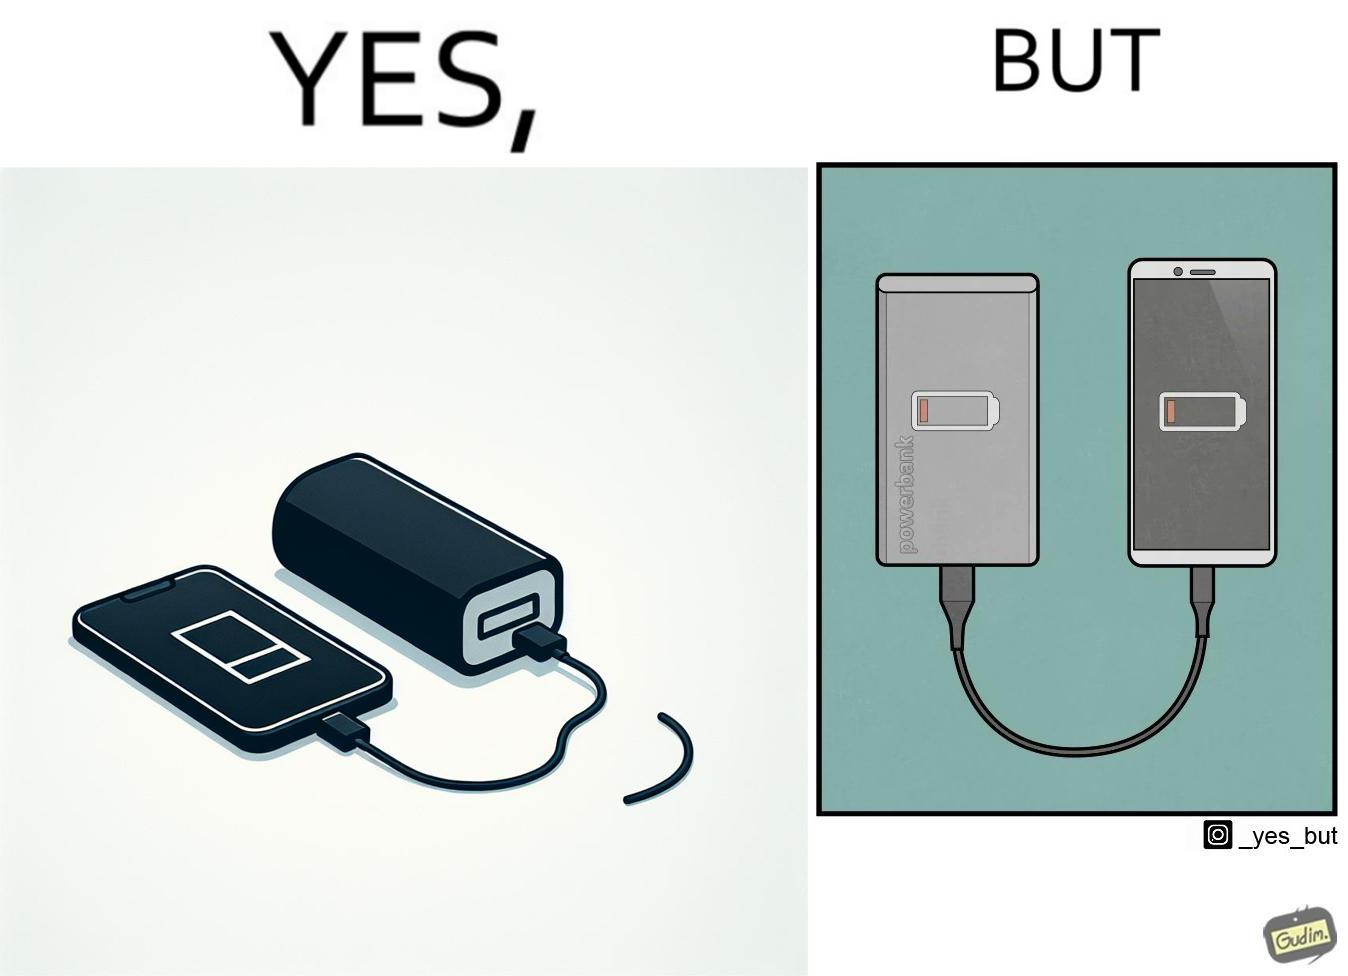Describe the contrast between the left and right parts of this image. In the left part of the image: A smartphone being charged by a power bank (portable charger)  via  a short cable. Smartphone screen shows it's battery has no power left. In the right part of the image: A smartphone being charged by a power bank (portable charger)  via  a short cable. Smartphone screen shows it's battery has no power left. Power bank also  has no power left, indicated via  a symbol drawn on top of it. 